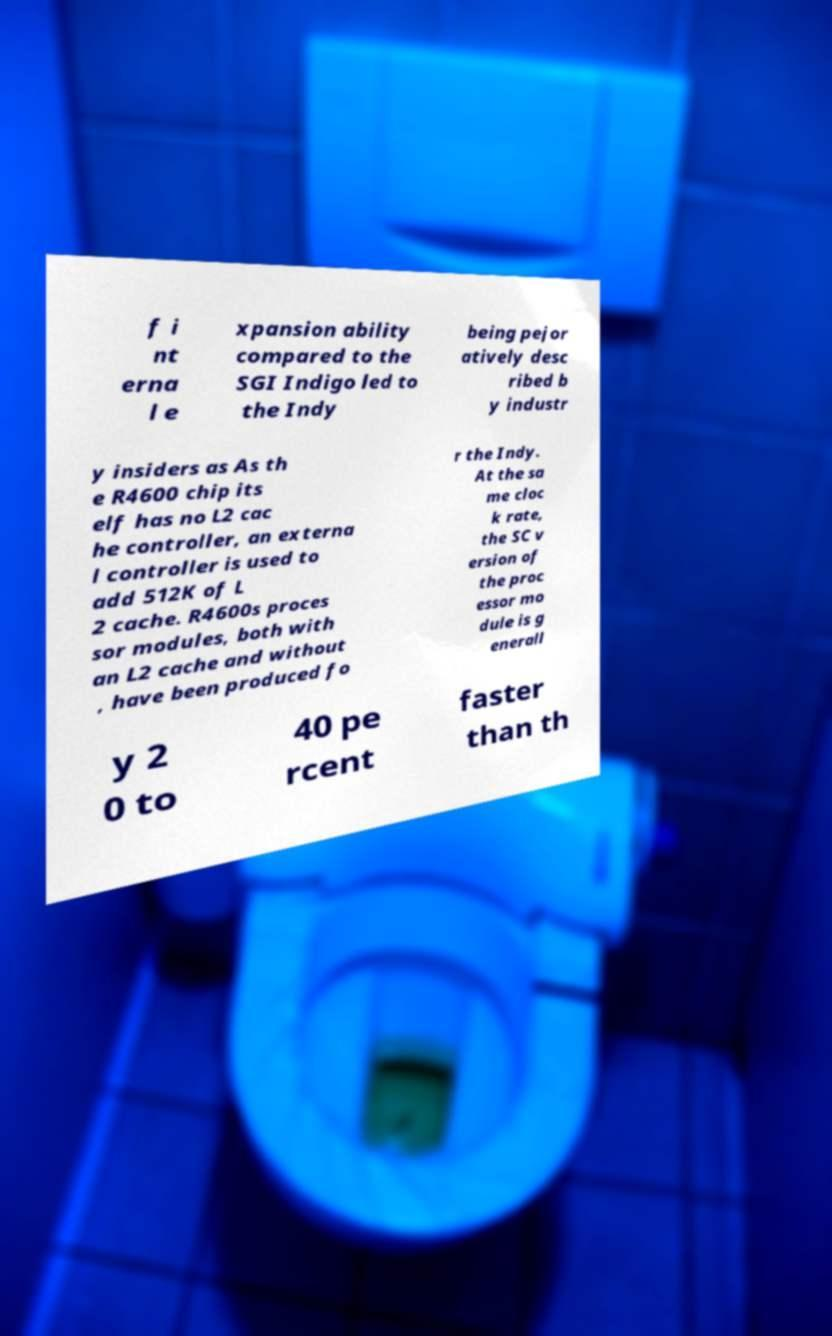There's text embedded in this image that I need extracted. Can you transcribe it verbatim? f i nt erna l e xpansion ability compared to the SGI Indigo led to the Indy being pejor atively desc ribed b y industr y insiders as As th e R4600 chip its elf has no L2 cac he controller, an externa l controller is used to add 512K of L 2 cache. R4600s proces sor modules, both with an L2 cache and without , have been produced fo r the Indy. At the sa me cloc k rate, the SC v ersion of the proc essor mo dule is g enerall y 2 0 to 40 pe rcent faster than th 